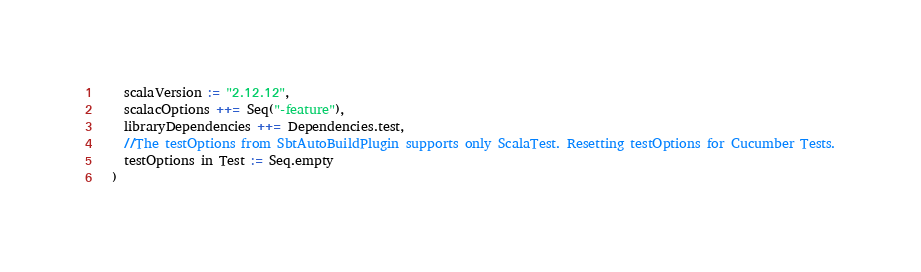<code> <loc_0><loc_0><loc_500><loc_500><_Scala_>    scalaVersion := "2.12.12",
    scalacOptions ++= Seq("-feature"),
    libraryDependencies ++= Dependencies.test,
    //The testOptions from SbtAutoBuildPlugin supports only ScalaTest. Resetting testOptions for Cucumber Tests.
    testOptions in Test := Seq.empty
  )
</code> 